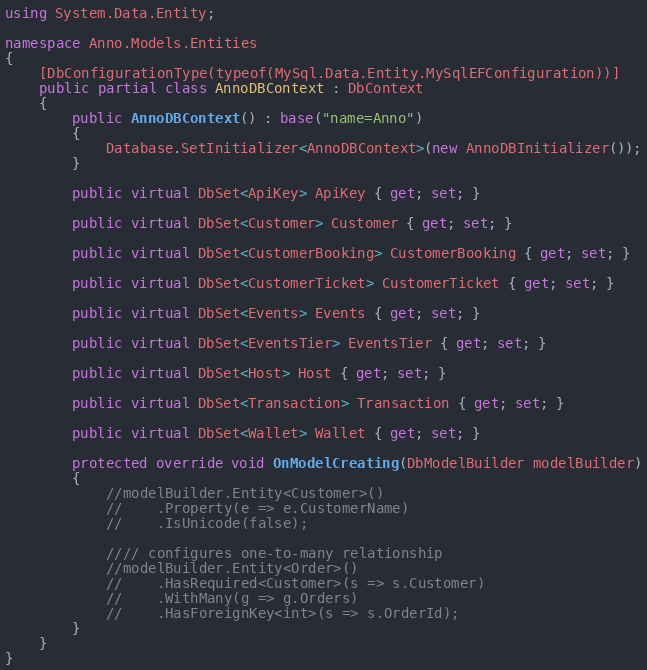Convert code to text. <code><loc_0><loc_0><loc_500><loc_500><_C#_>using System.Data.Entity;

namespace Anno.Models.Entities
{
	[DbConfigurationType(typeof(MySql.Data.Entity.MySqlEFConfiguration))]
	public partial class AnnoDBContext : DbContext
	{
		public AnnoDBContext() : base("name=Anno")
		{
			Database.SetInitializer<AnnoDBContext>(new AnnoDBInitializer());
		}

		public virtual DbSet<ApiKey> ApiKey { get; set; }

        public virtual DbSet<Customer> Customer { get; set; }

        public virtual DbSet<CustomerBooking> CustomerBooking { get; set; }

        public virtual DbSet<CustomerTicket> CustomerTicket { get; set; }

        public virtual DbSet<Events> Events { get; set; }

        public virtual DbSet<EventsTier> EventsTier { get; set; }

        public virtual DbSet<Host> Host { get; set; }

        public virtual DbSet<Transaction> Transaction { get; set; }

        public virtual DbSet<Wallet> Wallet { get; set; }
        
        protected override void OnModelCreating(DbModelBuilder modelBuilder)
		{
            //modelBuilder.Entity<Customer>()
            //    .Property(e => e.CustomerName)
            //    .IsUnicode(false);

            //// configures one-to-many relationship
            //modelBuilder.Entity<Order>()
            //    .HasRequired<Customer>(s => s.Customer)
            //    .WithMany(g => g.Orders)
            //    .HasForeignKey<int>(s => s.OrderId);
        }
	}
}
</code> 